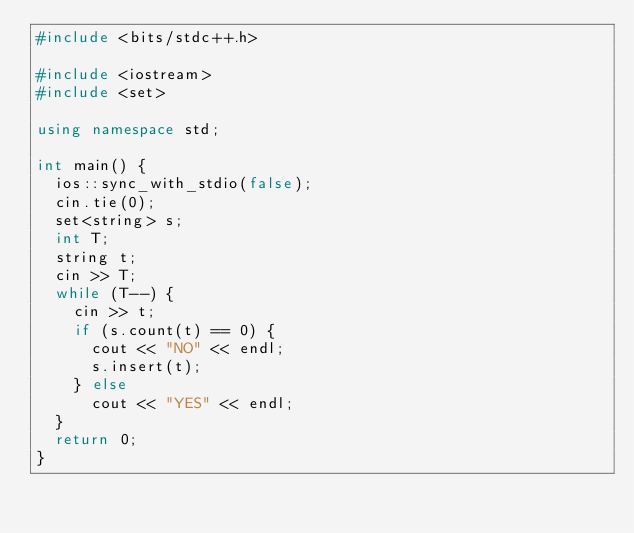<code> <loc_0><loc_0><loc_500><loc_500><_C++_>#include <bits/stdc++.h>

#include <iostream>
#include <set>

using namespace std;

int main() {
  ios::sync_with_stdio(false);
  cin.tie(0);
  set<string> s;
  int T;
  string t;
  cin >> T;
  while (T--) {
    cin >> t;
    if (s.count(t) == 0) {
      cout << "NO" << endl;
      s.insert(t);
    } else
      cout << "YES" << endl;
  }
  return 0;
}</code> 